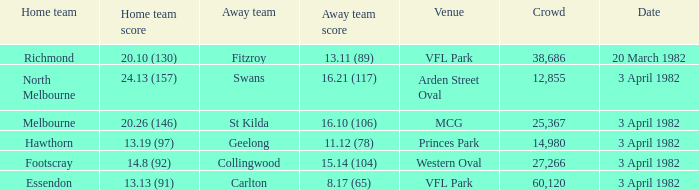When the guest team reached 1 24.13 (157). 